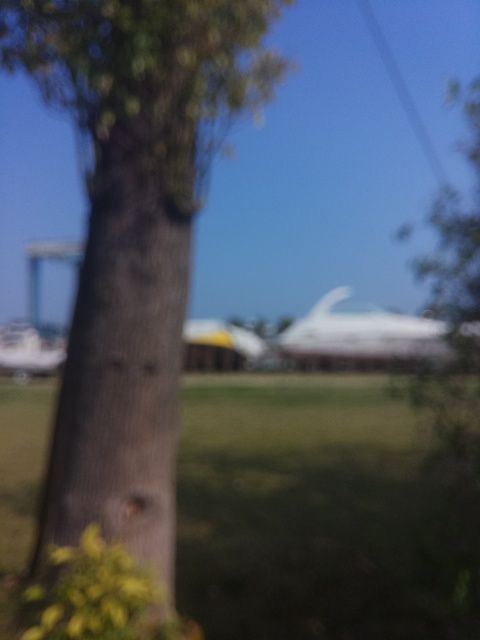What time of day could it be in this image? Given the natural, diffused light and lack of sharp shadows, it could be either early morning or late afternoon. However, the exact time is difficult to gauge due to the image's lack of focus. 